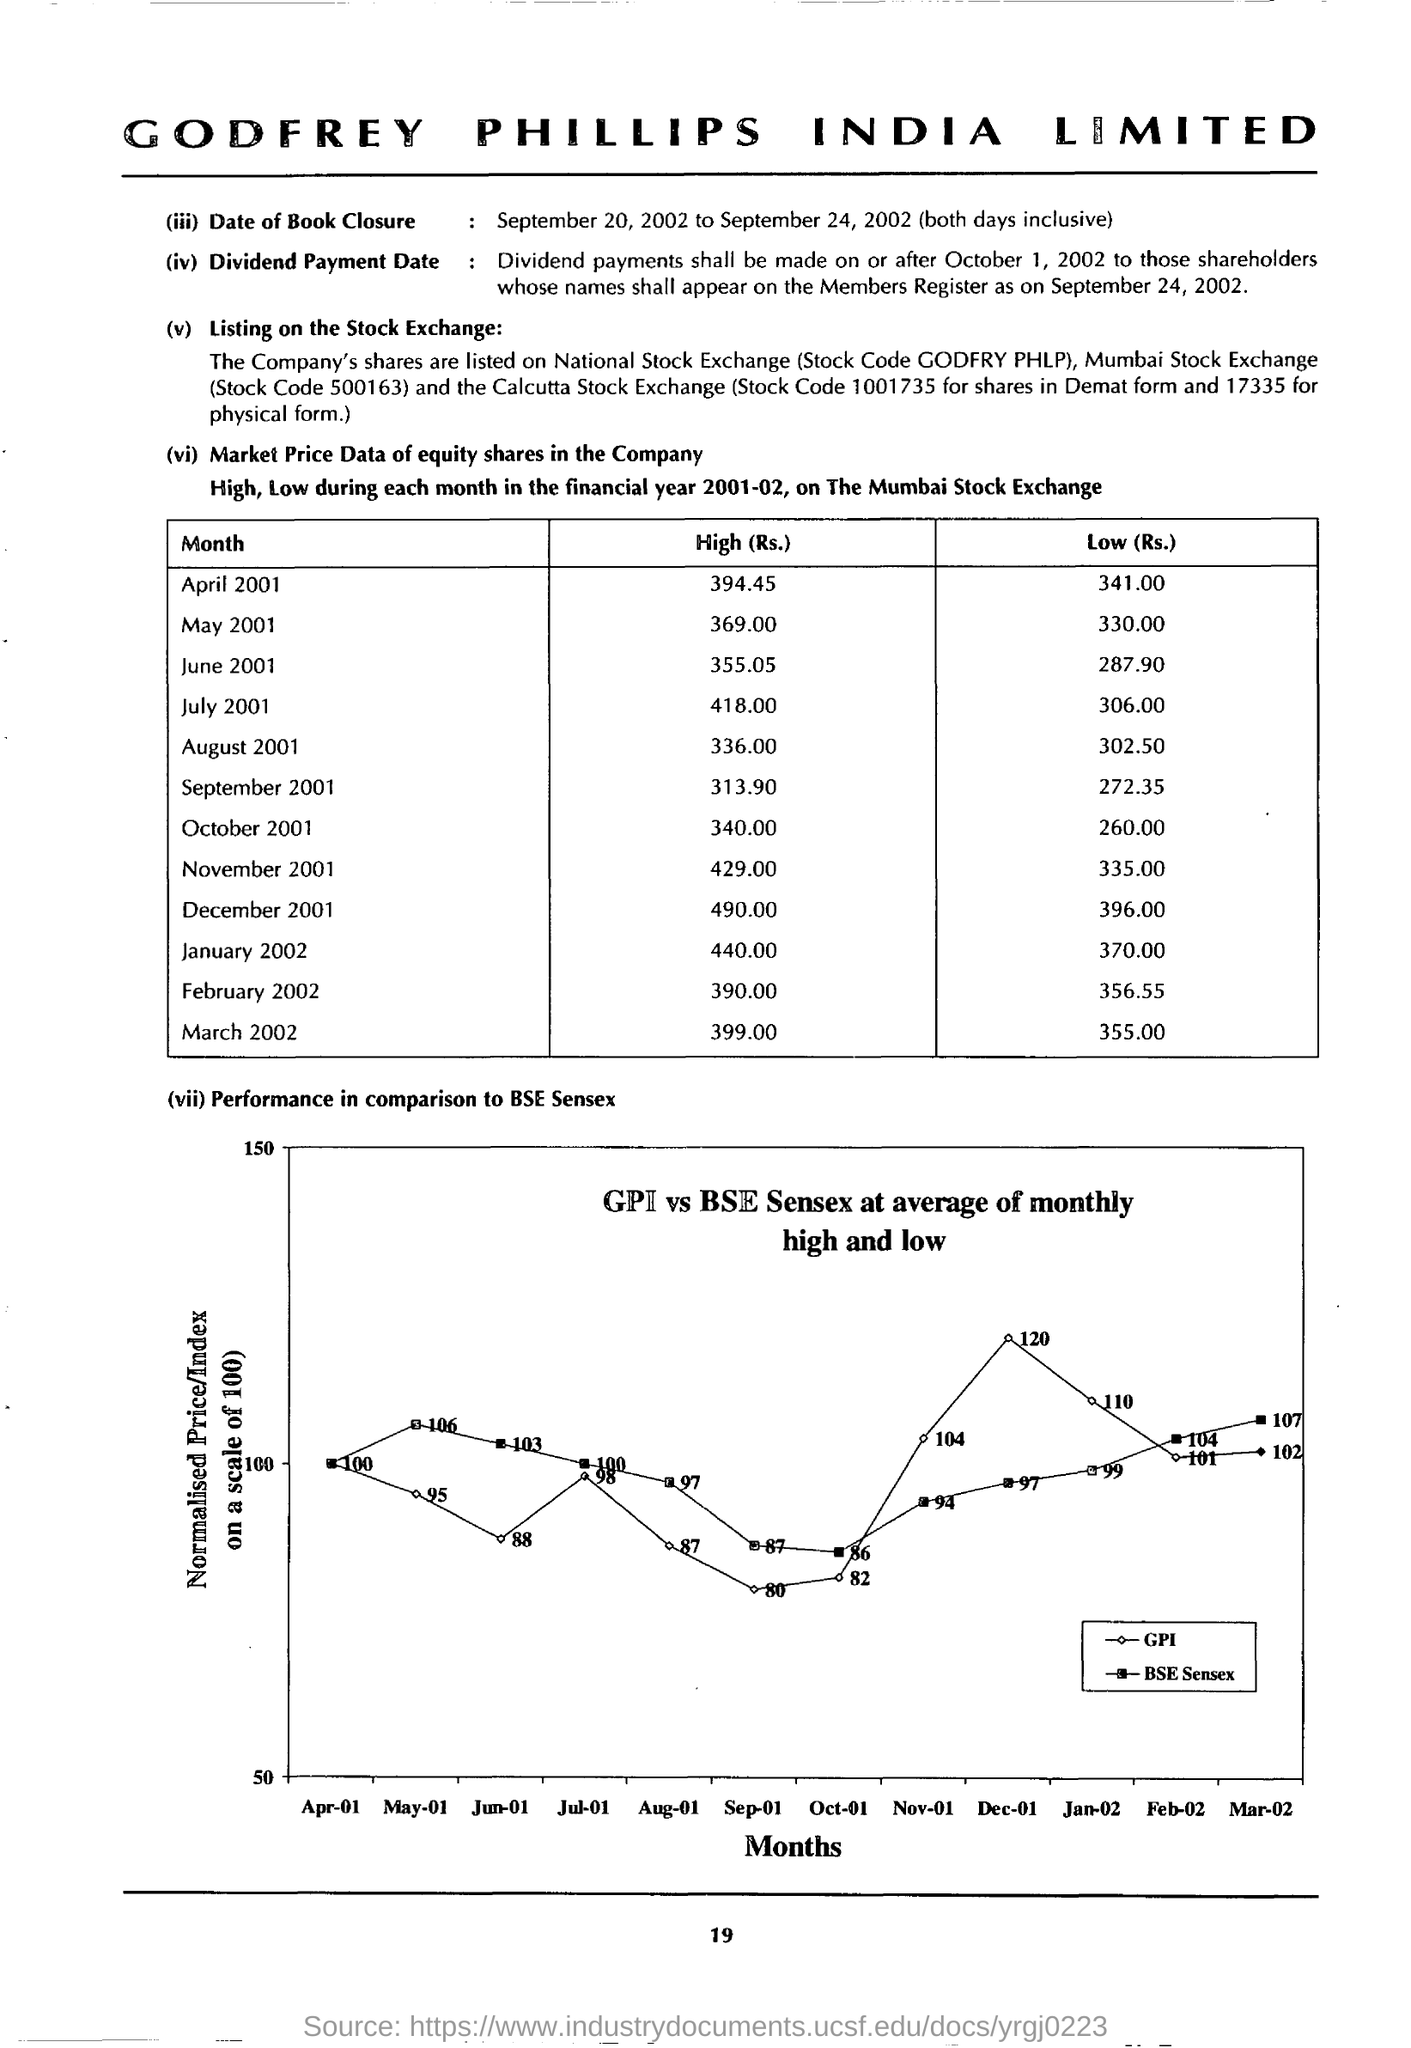What does the Y-axis of the graph describing the performance in comparison to BSE Sensex represent?
Make the answer very short. Normalised Price/Index on a scale of 100). What does the X-axis of the graph describing the performance in comparison to BSE Sensex represent?
Offer a terse response. Months. 